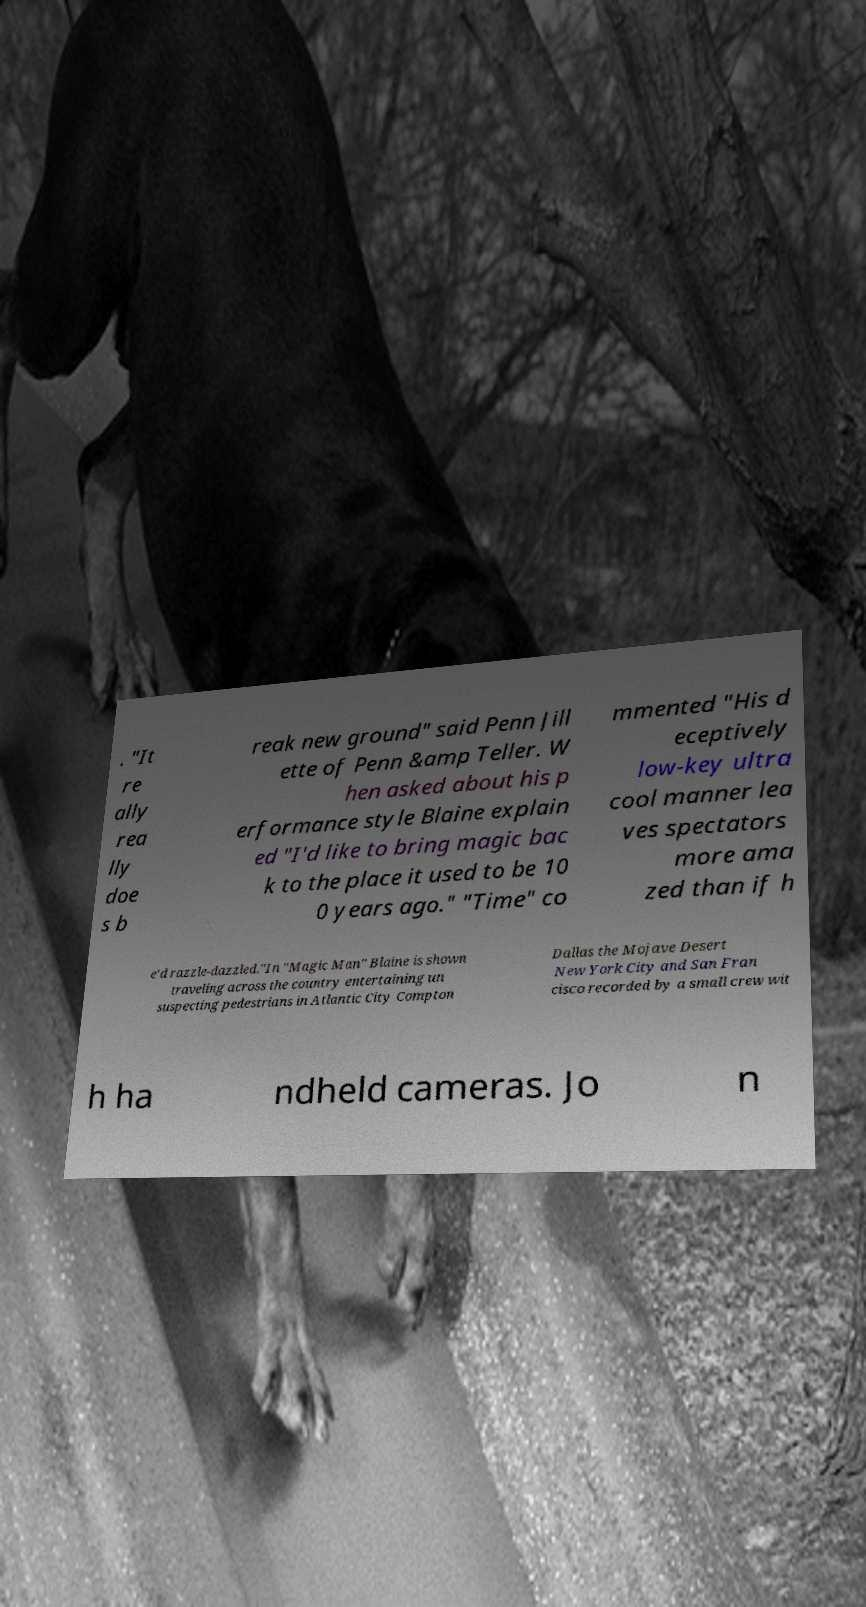Can you read and provide the text displayed in the image?This photo seems to have some interesting text. Can you extract and type it out for me? . "It re ally rea lly doe s b reak new ground" said Penn Jill ette of Penn &amp Teller. W hen asked about his p erformance style Blaine explain ed "I'd like to bring magic bac k to the place it used to be 10 0 years ago." "Time" co mmented "His d eceptively low-key ultra cool manner lea ves spectators more ama zed than if h e'd razzle-dazzled."In "Magic Man" Blaine is shown traveling across the country entertaining un suspecting pedestrians in Atlantic City Compton Dallas the Mojave Desert New York City and San Fran cisco recorded by a small crew wit h ha ndheld cameras. Jo n 